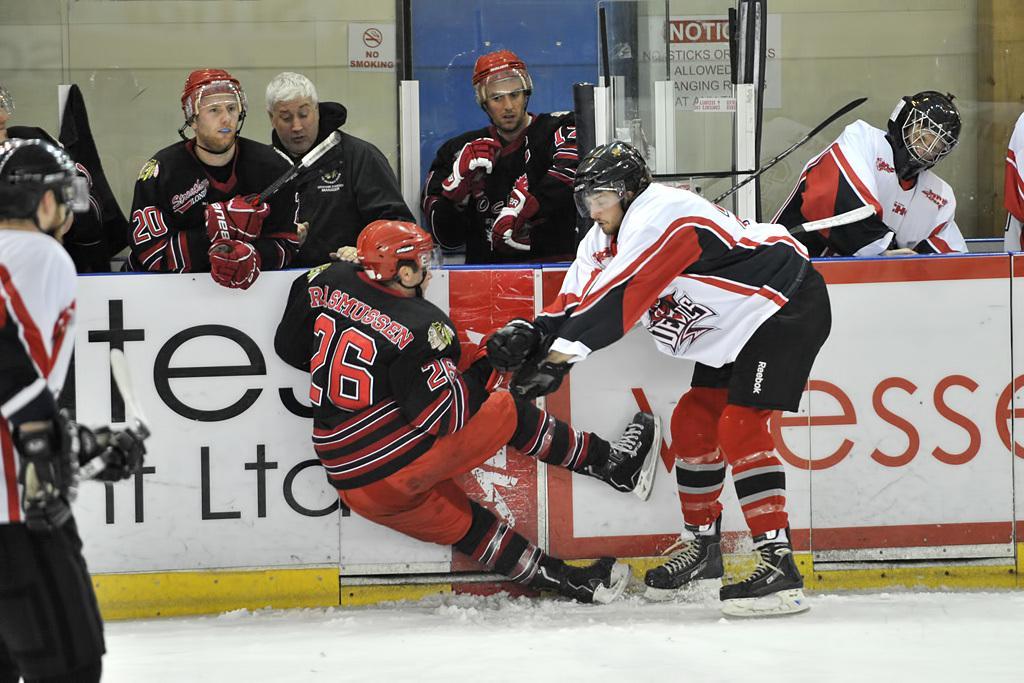How would you summarize this image in a sentence or two? In this image, there are four persons standing in front of the board. There is a person in the middle of the image holding another person's hand. There is an another person on the left side of the image holding and wearing clothes. 